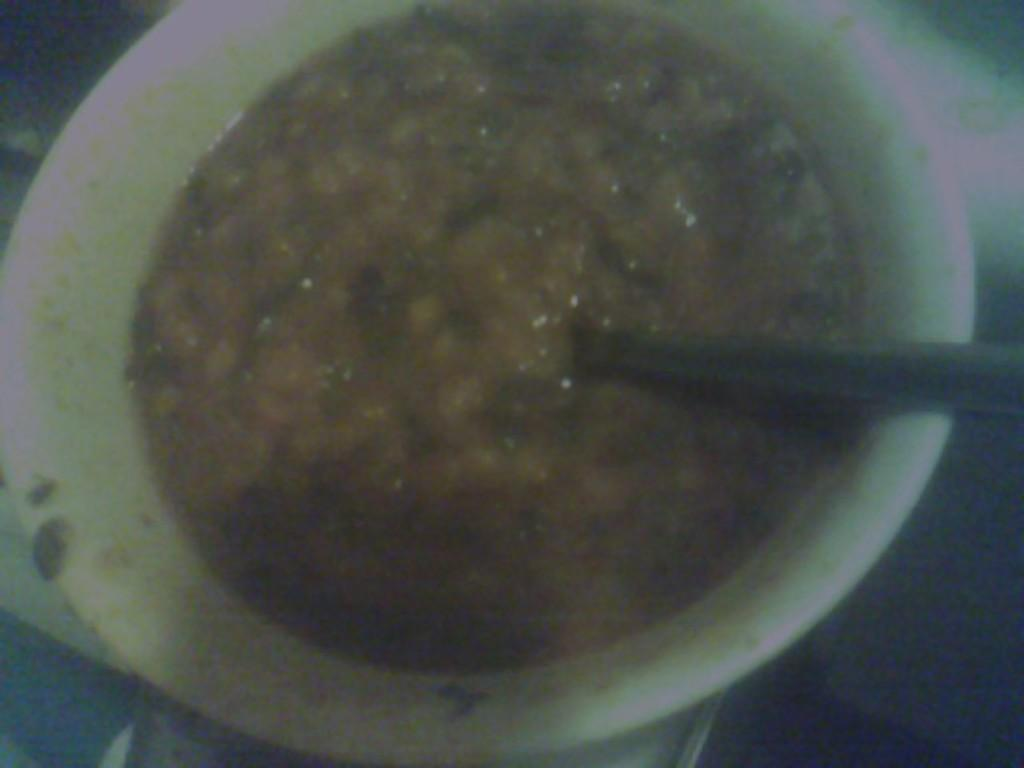What type of furniture is present in the image? There is a table in the image. What is on the table in the image? There is a bowl with food on the table. What utensil is visible on the table? There is a spoon visible on the table. What type of print can be seen in the frame on the table? There is no frame or print present on the table in the image. 